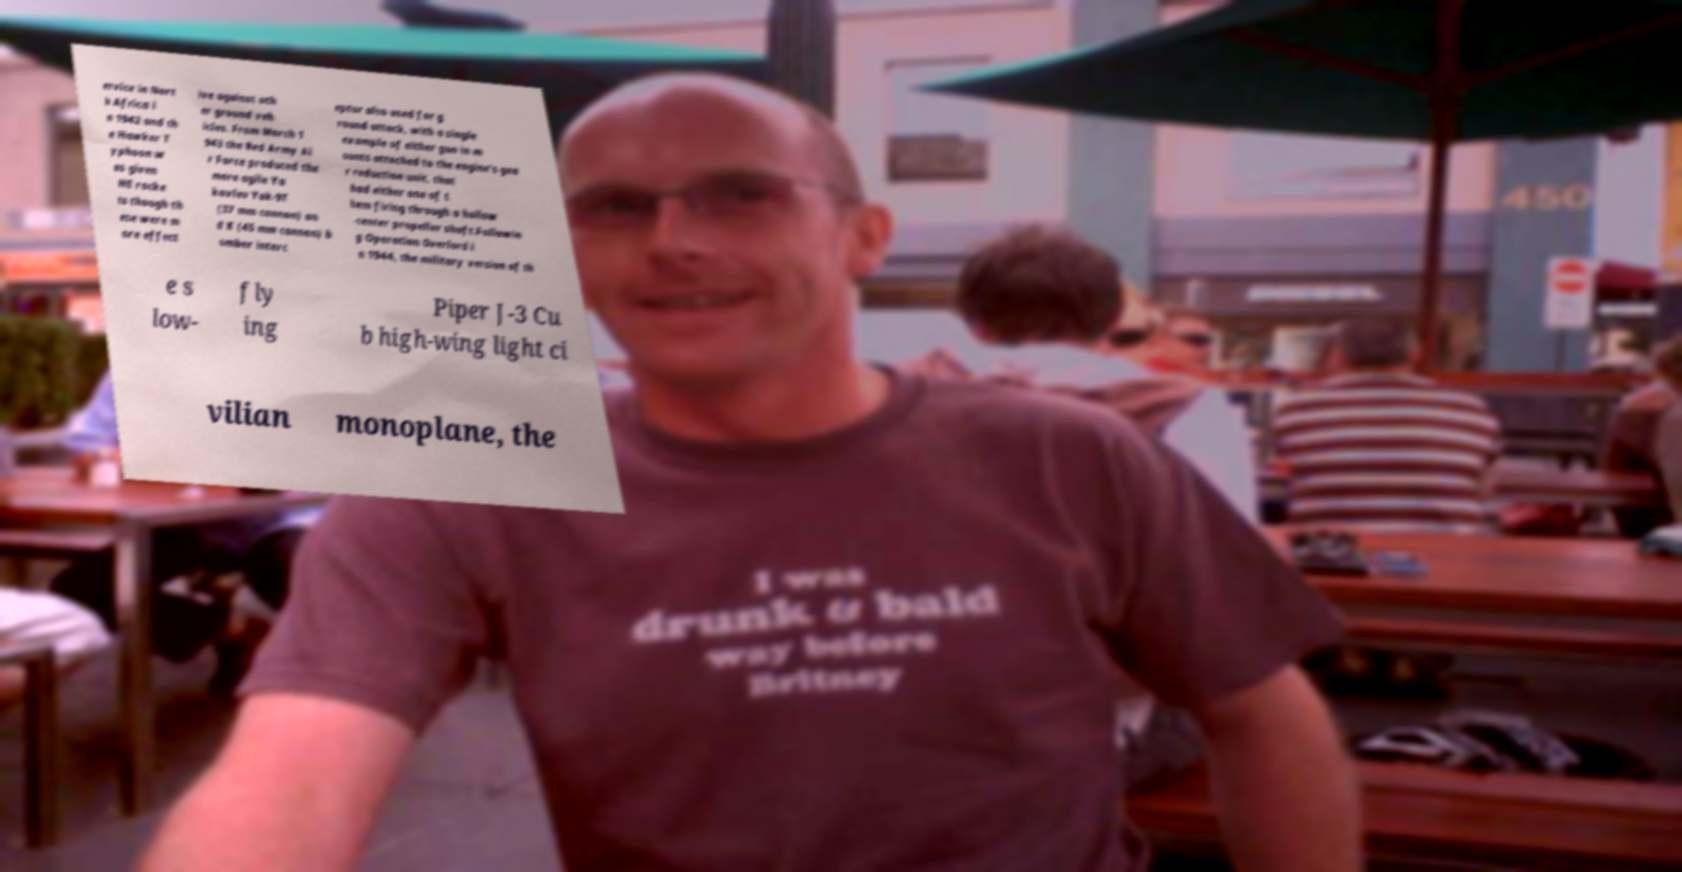I need the written content from this picture converted into text. Can you do that? ervice in Nort h Africa i n 1942 and th e Hawker T yphoon w as given HE rocke ts though th ese were m ore effect ive against oth er ground veh icles. From March 1 943 the Red Army Ai r Force produced the more agile Ya kovlev Yak-9T (37 mm cannon) an d K (45 mm cannon) b omber interc eptor also used for g round attack, with a single example of either gun in m ounts attached to the engine's gea r reduction unit, that had either one of t hem firing through a hollow -center propeller shaft.Followin g Operation Overlord i n 1944, the military version of th e s low- fly ing Piper J-3 Cu b high-wing light ci vilian monoplane, the 